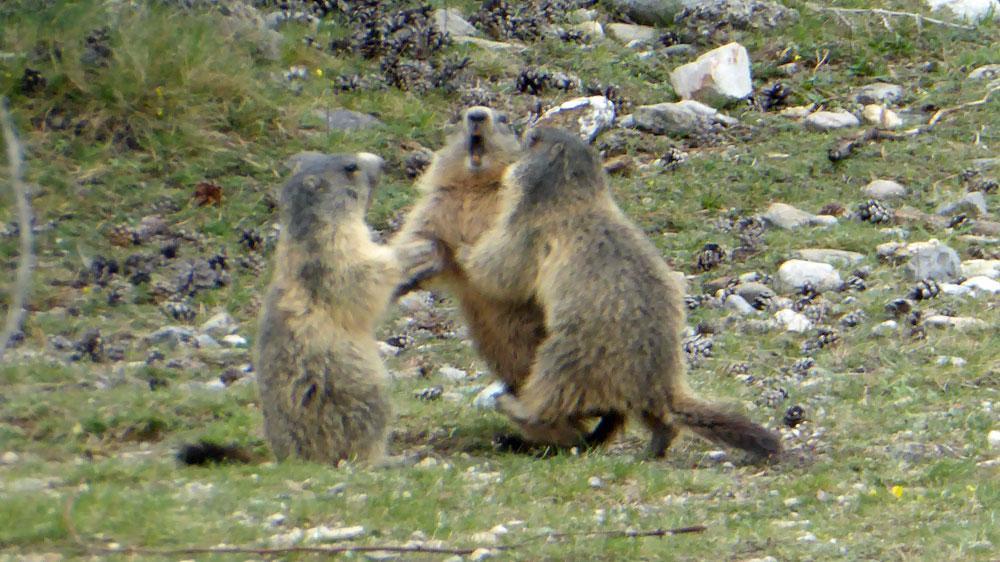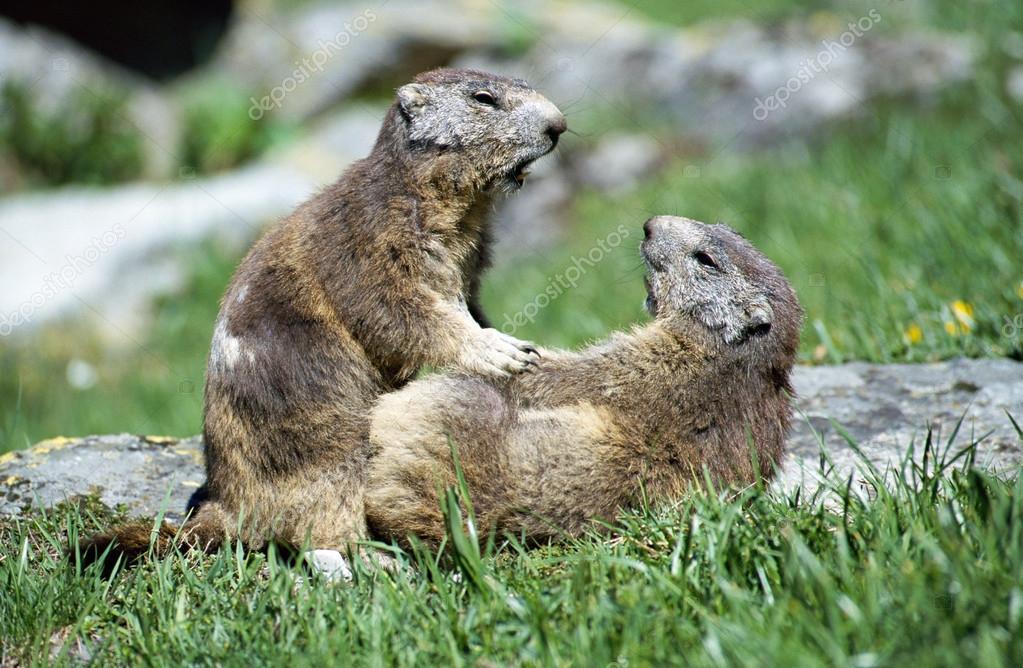The first image is the image on the left, the second image is the image on the right. Considering the images on both sides, is "An image contains one marmot, which stands upright in green grass with its body turned to the camera." valid? Answer yes or no. No. The first image is the image on the left, the second image is the image on the right. Evaluate the accuracy of this statement regarding the images: "The left image contains exactly one rodent standing on grass.". Is it true? Answer yes or no. No. 